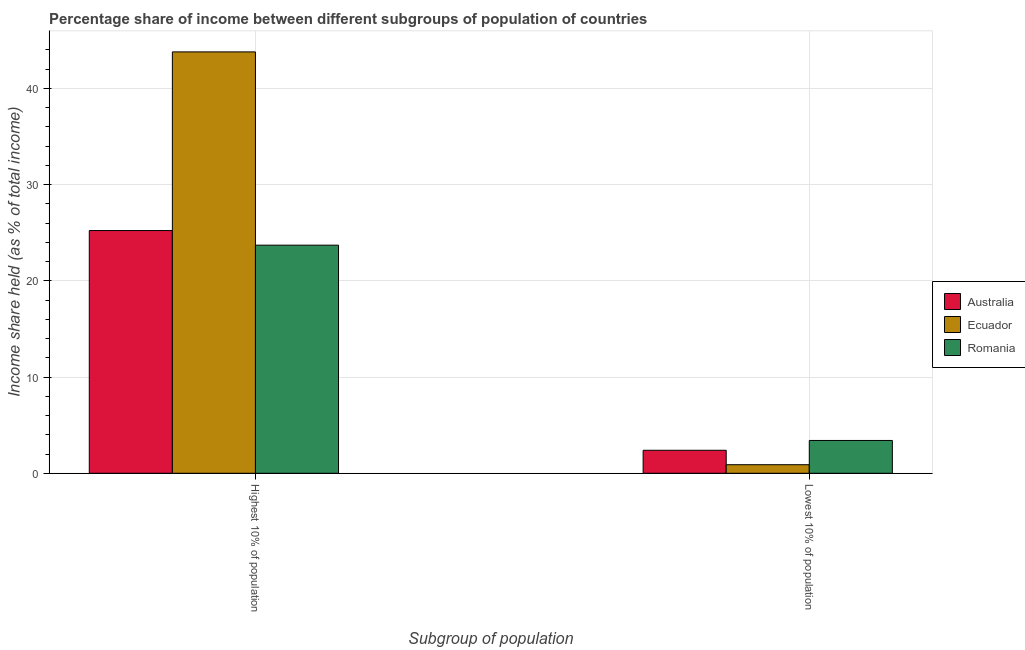How many groups of bars are there?
Ensure brevity in your answer.  2. Are the number of bars per tick equal to the number of legend labels?
Your response must be concise. Yes. How many bars are there on the 1st tick from the left?
Your response must be concise. 3. How many bars are there on the 2nd tick from the right?
Your response must be concise. 3. What is the label of the 2nd group of bars from the left?
Provide a short and direct response. Lowest 10% of population. What is the income share held by highest 10% of the population in Australia?
Your answer should be compact. 25.23. Across all countries, what is the maximum income share held by lowest 10% of the population?
Offer a terse response. 3.41. Across all countries, what is the minimum income share held by lowest 10% of the population?
Your response must be concise. 0.89. In which country was the income share held by lowest 10% of the population maximum?
Provide a short and direct response. Romania. In which country was the income share held by lowest 10% of the population minimum?
Your answer should be very brief. Ecuador. What is the total income share held by highest 10% of the population in the graph?
Make the answer very short. 92.74. What is the difference between the income share held by lowest 10% of the population in Ecuador and that in Romania?
Provide a succinct answer. -2.52. What is the difference between the income share held by lowest 10% of the population in Australia and the income share held by highest 10% of the population in Romania?
Offer a very short reply. -21.32. What is the average income share held by lowest 10% of the population per country?
Make the answer very short. 2.23. What is the difference between the income share held by highest 10% of the population and income share held by lowest 10% of the population in Ecuador?
Keep it short and to the point. 42.91. What is the ratio of the income share held by highest 10% of the population in Romania to that in Australia?
Provide a short and direct response. 0.94. What does the 2nd bar from the left in Highest 10% of population represents?
Give a very brief answer. Ecuador. What does the 1st bar from the right in Highest 10% of population represents?
Ensure brevity in your answer.  Romania. How many bars are there?
Your response must be concise. 6. How many countries are there in the graph?
Your answer should be very brief. 3. What is the difference between two consecutive major ticks on the Y-axis?
Keep it short and to the point. 10. Are the values on the major ticks of Y-axis written in scientific E-notation?
Provide a short and direct response. No. Does the graph contain any zero values?
Offer a very short reply. No. Does the graph contain grids?
Offer a terse response. Yes. Where does the legend appear in the graph?
Ensure brevity in your answer.  Center right. What is the title of the graph?
Provide a succinct answer. Percentage share of income between different subgroups of population of countries. What is the label or title of the X-axis?
Offer a terse response. Subgroup of population. What is the label or title of the Y-axis?
Your answer should be compact. Income share held (as % of total income). What is the Income share held (as % of total income) in Australia in Highest 10% of population?
Give a very brief answer. 25.23. What is the Income share held (as % of total income) of Ecuador in Highest 10% of population?
Provide a short and direct response. 43.8. What is the Income share held (as % of total income) in Romania in Highest 10% of population?
Offer a terse response. 23.71. What is the Income share held (as % of total income) of Australia in Lowest 10% of population?
Provide a short and direct response. 2.39. What is the Income share held (as % of total income) of Ecuador in Lowest 10% of population?
Offer a very short reply. 0.89. What is the Income share held (as % of total income) in Romania in Lowest 10% of population?
Keep it short and to the point. 3.41. Across all Subgroup of population, what is the maximum Income share held (as % of total income) in Australia?
Your response must be concise. 25.23. Across all Subgroup of population, what is the maximum Income share held (as % of total income) of Ecuador?
Provide a succinct answer. 43.8. Across all Subgroup of population, what is the maximum Income share held (as % of total income) of Romania?
Provide a short and direct response. 23.71. Across all Subgroup of population, what is the minimum Income share held (as % of total income) of Australia?
Provide a succinct answer. 2.39. Across all Subgroup of population, what is the minimum Income share held (as % of total income) in Ecuador?
Provide a succinct answer. 0.89. Across all Subgroup of population, what is the minimum Income share held (as % of total income) of Romania?
Give a very brief answer. 3.41. What is the total Income share held (as % of total income) of Australia in the graph?
Offer a terse response. 27.62. What is the total Income share held (as % of total income) of Ecuador in the graph?
Offer a very short reply. 44.69. What is the total Income share held (as % of total income) of Romania in the graph?
Offer a very short reply. 27.12. What is the difference between the Income share held (as % of total income) in Australia in Highest 10% of population and that in Lowest 10% of population?
Your answer should be compact. 22.84. What is the difference between the Income share held (as % of total income) of Ecuador in Highest 10% of population and that in Lowest 10% of population?
Provide a succinct answer. 42.91. What is the difference between the Income share held (as % of total income) in Romania in Highest 10% of population and that in Lowest 10% of population?
Your answer should be very brief. 20.3. What is the difference between the Income share held (as % of total income) in Australia in Highest 10% of population and the Income share held (as % of total income) in Ecuador in Lowest 10% of population?
Ensure brevity in your answer.  24.34. What is the difference between the Income share held (as % of total income) of Australia in Highest 10% of population and the Income share held (as % of total income) of Romania in Lowest 10% of population?
Offer a terse response. 21.82. What is the difference between the Income share held (as % of total income) of Ecuador in Highest 10% of population and the Income share held (as % of total income) of Romania in Lowest 10% of population?
Your response must be concise. 40.39. What is the average Income share held (as % of total income) in Australia per Subgroup of population?
Provide a short and direct response. 13.81. What is the average Income share held (as % of total income) in Ecuador per Subgroup of population?
Your response must be concise. 22.34. What is the average Income share held (as % of total income) in Romania per Subgroup of population?
Ensure brevity in your answer.  13.56. What is the difference between the Income share held (as % of total income) in Australia and Income share held (as % of total income) in Ecuador in Highest 10% of population?
Make the answer very short. -18.57. What is the difference between the Income share held (as % of total income) in Australia and Income share held (as % of total income) in Romania in Highest 10% of population?
Offer a very short reply. 1.52. What is the difference between the Income share held (as % of total income) in Ecuador and Income share held (as % of total income) in Romania in Highest 10% of population?
Your answer should be compact. 20.09. What is the difference between the Income share held (as % of total income) of Australia and Income share held (as % of total income) of Romania in Lowest 10% of population?
Make the answer very short. -1.02. What is the difference between the Income share held (as % of total income) in Ecuador and Income share held (as % of total income) in Romania in Lowest 10% of population?
Offer a terse response. -2.52. What is the ratio of the Income share held (as % of total income) of Australia in Highest 10% of population to that in Lowest 10% of population?
Keep it short and to the point. 10.56. What is the ratio of the Income share held (as % of total income) in Ecuador in Highest 10% of population to that in Lowest 10% of population?
Offer a terse response. 49.21. What is the ratio of the Income share held (as % of total income) in Romania in Highest 10% of population to that in Lowest 10% of population?
Offer a very short reply. 6.95. What is the difference between the highest and the second highest Income share held (as % of total income) of Australia?
Ensure brevity in your answer.  22.84. What is the difference between the highest and the second highest Income share held (as % of total income) in Ecuador?
Provide a succinct answer. 42.91. What is the difference between the highest and the second highest Income share held (as % of total income) in Romania?
Your response must be concise. 20.3. What is the difference between the highest and the lowest Income share held (as % of total income) of Australia?
Your answer should be compact. 22.84. What is the difference between the highest and the lowest Income share held (as % of total income) in Ecuador?
Your answer should be compact. 42.91. What is the difference between the highest and the lowest Income share held (as % of total income) of Romania?
Your answer should be very brief. 20.3. 